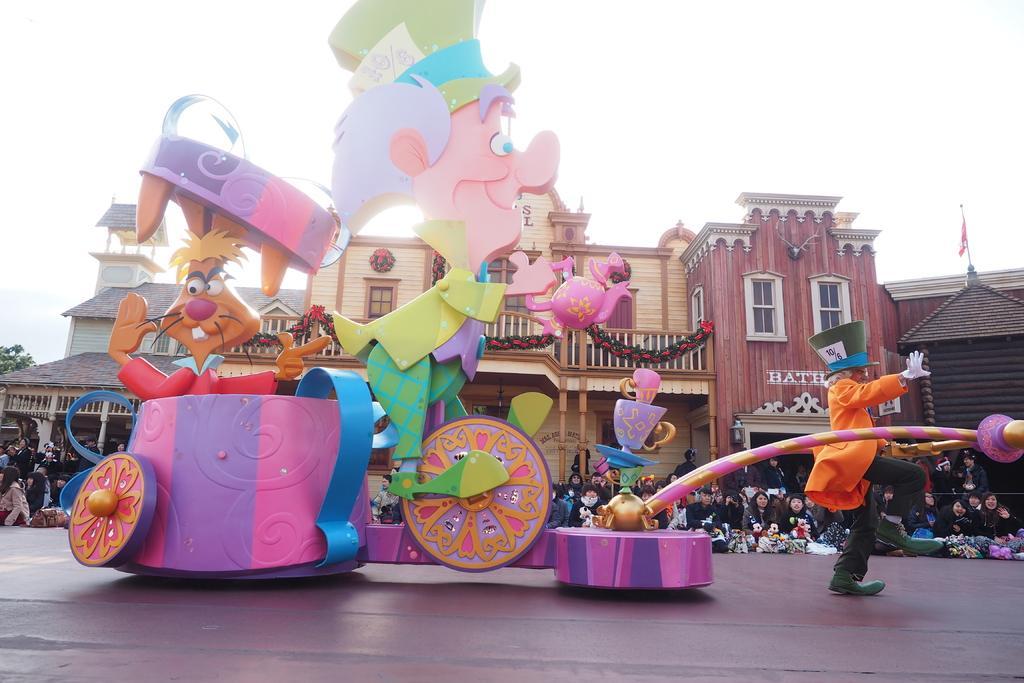Please provide a concise description of this image. In this image we can see a few people, there are buildings, windows, there is a person holding different costume, there is a toy vehicle on the road, there is a flag, tree, also we can see the sky. 